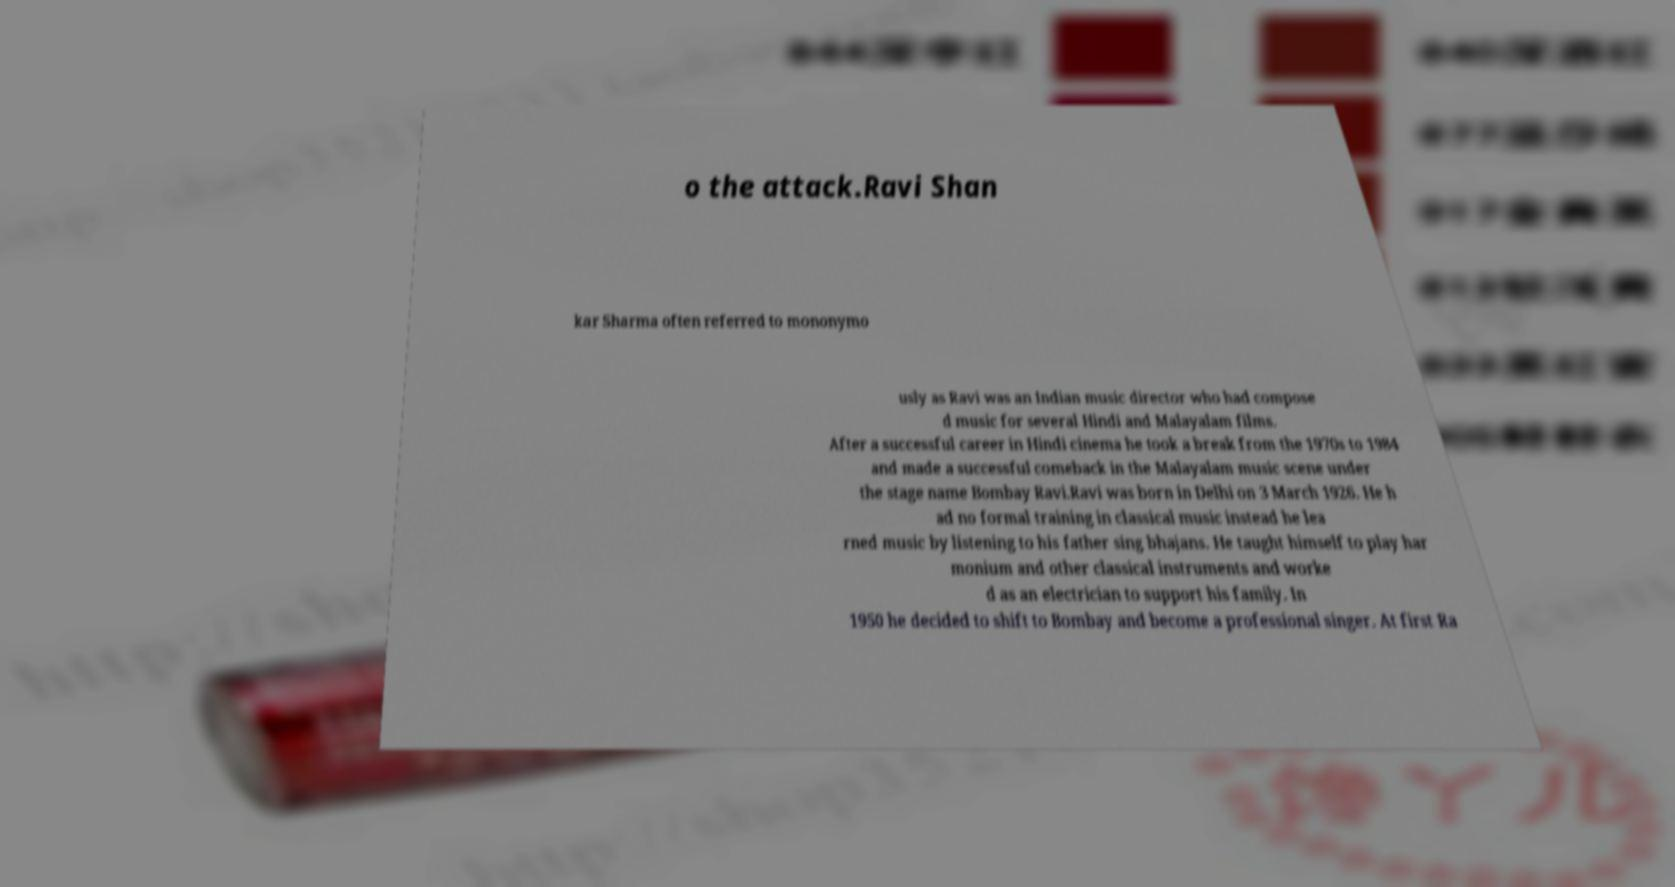Can you read and provide the text displayed in the image?This photo seems to have some interesting text. Can you extract and type it out for me? o the attack.Ravi Shan kar Sharma often referred to mononymo usly as Ravi was an Indian music director who had compose d music for several Hindi and Malayalam films. After a successful career in Hindi cinema he took a break from the 1970s to 1984 and made a successful comeback in the Malayalam music scene under the stage name Bombay Ravi.Ravi was born in Delhi on 3 March 1926. He h ad no formal training in classical music instead he lea rned music by listening to his father sing bhajans. He taught himself to play har monium and other classical instruments and worke d as an electrician to support his family. In 1950 he decided to shift to Bombay and become a professional singer. At first Ra 